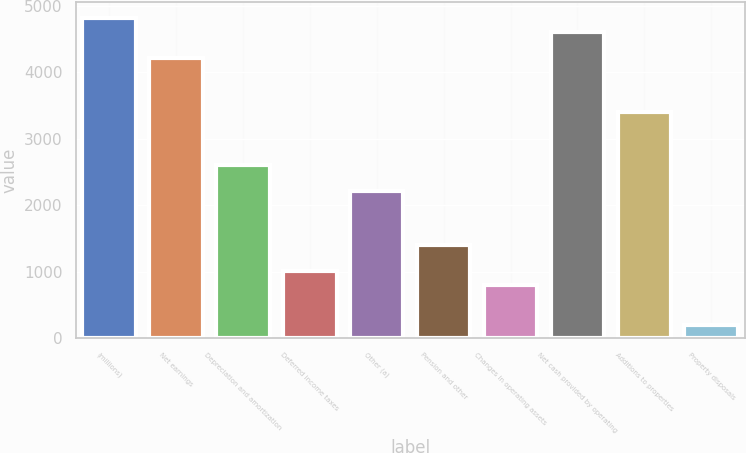Convert chart to OTSL. <chart><loc_0><loc_0><loc_500><loc_500><bar_chart><fcel>(millions)<fcel>Net earnings<fcel>Depreciation and amortization<fcel>Deferred income taxes<fcel>Other (a)<fcel>Pension and other<fcel>Changes in operating assets<fcel>Net cash provided by operating<fcel>Additions to properties<fcel>Property disposals<nl><fcel>4812.02<fcel>4210.73<fcel>2607.29<fcel>1003.85<fcel>2206.43<fcel>1404.71<fcel>803.42<fcel>4611.59<fcel>3409.01<fcel>202.13<nl></chart> 